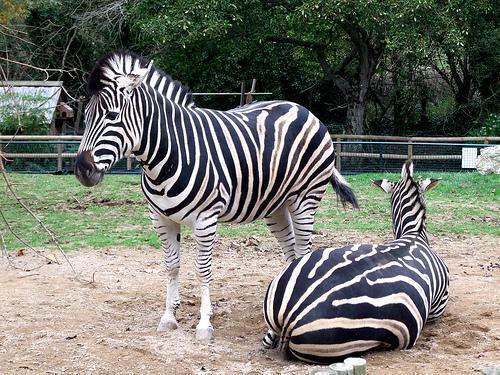How many zebras are there?
Give a very brief answer. 2. How many kangaroos are in this image?
Give a very brief answer. 0. 